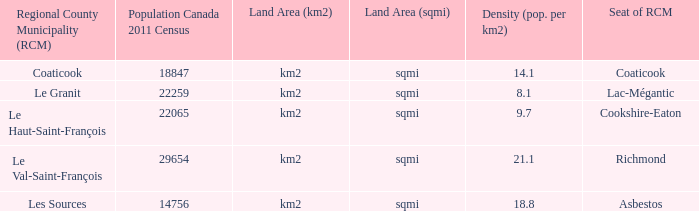For the rcm with 18,847 residents, what is the size of its land area? Km2 (sqmi). 